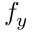Convert formula to latex. <formula><loc_0><loc_0><loc_500><loc_500>f _ { y }</formula> 